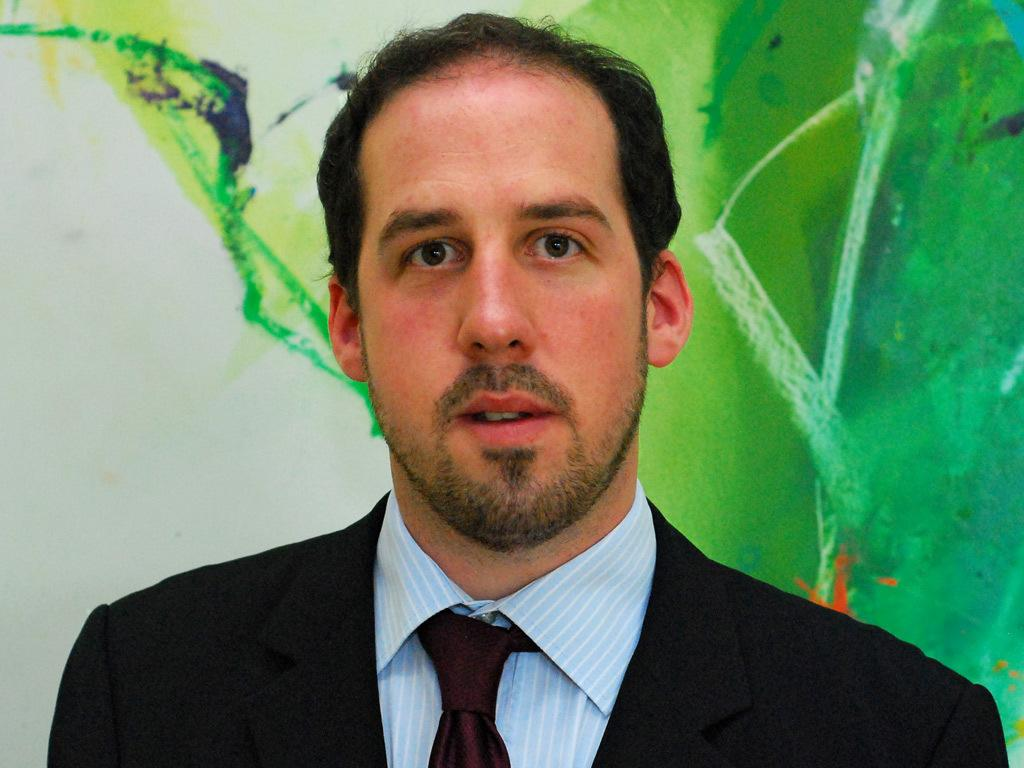Who is present in the image? There is a man in the image. What is the man wearing? The man is wearing a suit. What can be seen in the background of the image? There is a board in the background of the image. What type of vacation is the man planning based on the image? There is no information about a vacation in the image, as it only shows a man wearing a suit and a board in the background. How many trucks can be seen in the image? There are no trucks present in the image. 